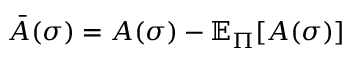<formula> <loc_0><loc_0><loc_500><loc_500>\ B a r { A } ( \sigma ) = A ( \sigma ) - \mathbb { E } _ { \Pi } [ A ( \sigma ) ]</formula> 